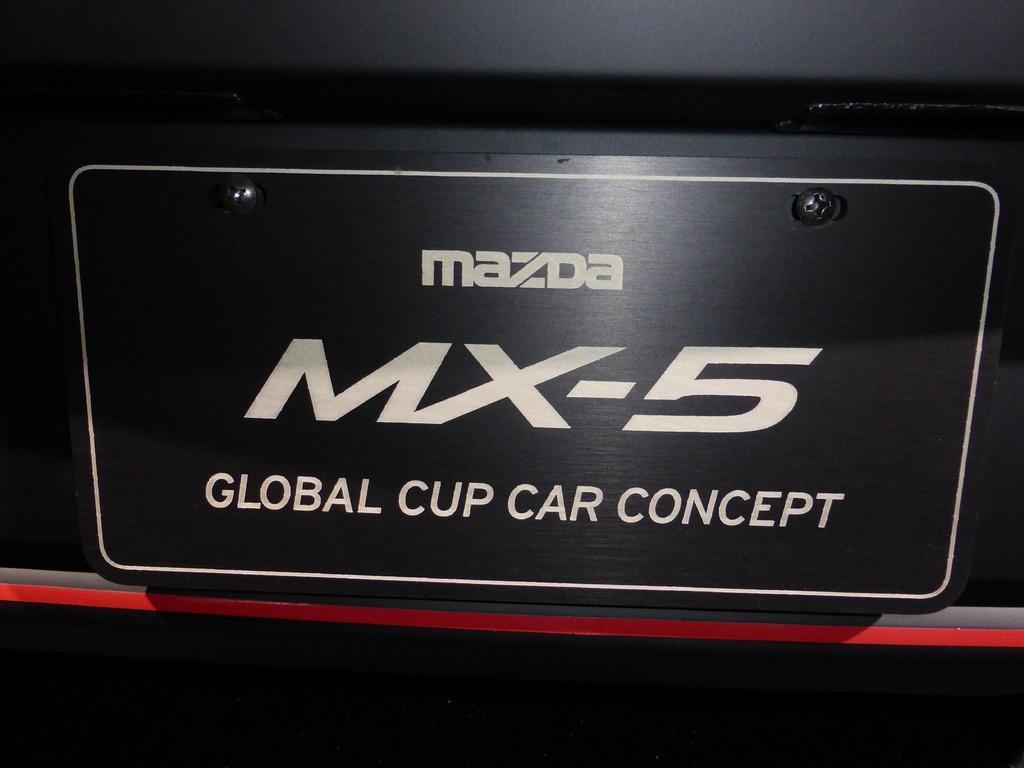How would you summarize this image in a sentence or two? In this image I can see there is the name in white color on a black color board. In the middle there are black color screws. 